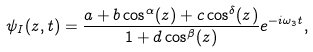<formula> <loc_0><loc_0><loc_500><loc_500>\psi _ { I } ( z , t ) = \frac { a + b \cos ^ { \alpha } ( z ) + c \cos ^ { \delta } ( z ) } { 1 + d \cos ^ { \beta } ( z ) } e ^ { - i \omega _ { 3 } t } ,</formula> 